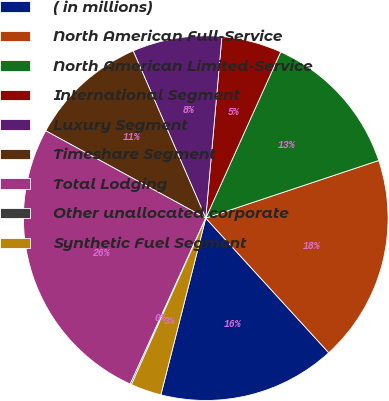Convert chart to OTSL. <chart><loc_0><loc_0><loc_500><loc_500><pie_chart><fcel>( in millions)<fcel>North American Full-Service<fcel>North American Limited-Service<fcel>International Segment<fcel>Luxury Segment<fcel>Timeshare Segment<fcel>Total Lodging<fcel>Other unallocated corporate<fcel>Synthetic Fuel Segment<nl><fcel>15.74%<fcel>18.34%<fcel>13.14%<fcel>5.33%<fcel>7.93%<fcel>10.53%<fcel>26.15%<fcel>0.12%<fcel>2.72%<nl></chart> 